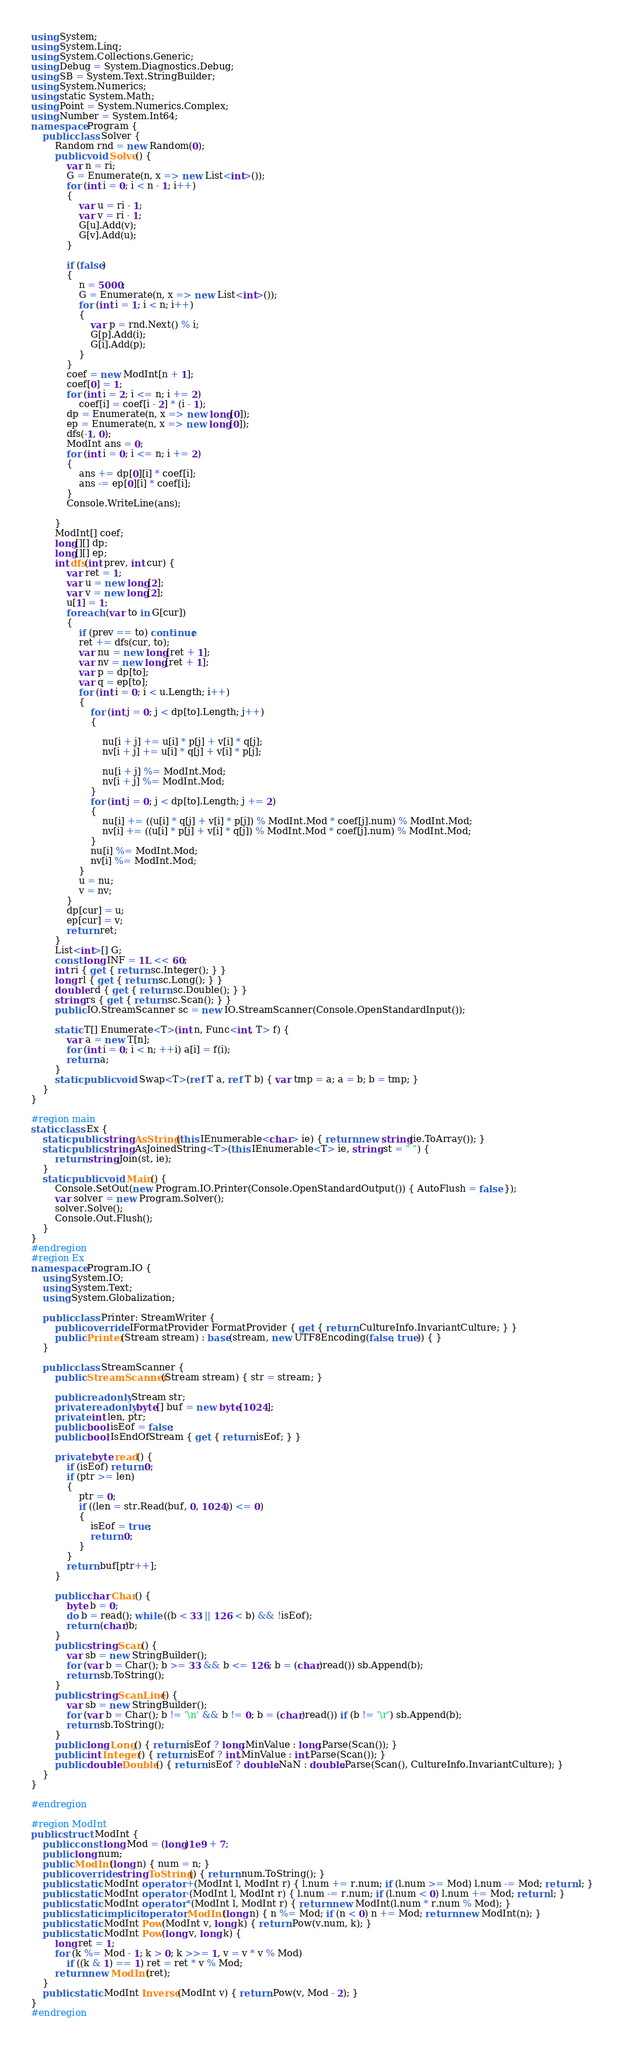<code> <loc_0><loc_0><loc_500><loc_500><_C#_>using System;
using System.Linq;
using System.Collections.Generic;
using Debug = System.Diagnostics.Debug;
using SB = System.Text.StringBuilder;
using System.Numerics;
using static System.Math;
using Point = System.Numerics.Complex;
using Number = System.Int64;
namespace Program {
    public class Solver {
        Random rnd = new Random(0);
        public void Solve() {
            var n = ri;
            G = Enumerate(n, x => new List<int>());
            for (int i = 0; i < n - 1; i++)
            {
                var u = ri - 1;
                var v = ri - 1;
                G[u].Add(v);
                G[v].Add(u);
            }

            if (false)
            {
                n = 5000;
                G = Enumerate(n, x => new List<int>());
                for (int i = 1; i < n; i++)
                {
                    var p = rnd.Next() % i;
                    G[p].Add(i);
                    G[i].Add(p);
                }
            }
            coef = new ModInt[n + 1];
            coef[0] = 1;
            for (int i = 2; i <= n; i += 2)
                coef[i] = coef[i - 2] * (i - 1);
            dp = Enumerate(n, x => new long[0]);
            ep = Enumerate(n, x => new long[0]);
            dfs(-1, 0);
            ModInt ans = 0;
            for (int i = 0; i <= n; i += 2)
            {
                ans += dp[0][i] * coef[i];
                ans -= ep[0][i] * coef[i];
            }
            Console.WriteLine(ans);

        }
        ModInt[] coef;
        long[][] dp;
        long[][] ep;
        int dfs(int prev, int cur) {
            var ret = 1;
            var u = new long[2];
            var v = new long[2];
            u[1] = 1;
            foreach (var to in G[cur])
            {
                if (prev == to) continue;
                ret += dfs(cur, to);
                var nu = new long[ret + 1];
                var nv = new long[ret + 1];
                var p = dp[to];
                var q = ep[to];
                for (int i = 0; i < u.Length; i++)
                {
                    for (int j = 0; j < dp[to].Length; j++)
                    {

                        nu[i + j] += u[i] * p[j] + v[i] * q[j];
                        nv[i + j] += u[i] * q[j] + v[i] * p[j];

                        nu[i + j] %= ModInt.Mod;
                        nv[i + j] %= ModInt.Mod;
                    }
                    for (int j = 0; j < dp[to].Length; j += 2)
                    {
                        nu[i] += ((u[i] * q[j] + v[i] * p[j]) % ModInt.Mod * coef[j].num) % ModInt.Mod;
                        nv[i] += ((u[i] * p[j] + v[i] * q[j]) % ModInt.Mod * coef[j].num) % ModInt.Mod;
                    }
                    nu[i] %= ModInt.Mod;
                    nv[i] %= ModInt.Mod;
                }
                u = nu;
                v = nv;
            }
            dp[cur] = u;
            ep[cur] = v;
            return ret;
        }
        List<int>[] G;
        const long INF = 1L << 60;
        int ri { get { return sc.Integer(); } }
        long rl { get { return sc.Long(); } }
        double rd { get { return sc.Double(); } }
        string rs { get { return sc.Scan(); } }
        public IO.StreamScanner sc = new IO.StreamScanner(Console.OpenStandardInput());

        static T[] Enumerate<T>(int n, Func<int, T> f) {
            var a = new T[n];
            for (int i = 0; i < n; ++i) a[i] = f(i);
            return a;
        }
        static public void Swap<T>(ref T a, ref T b) { var tmp = a; a = b; b = tmp; }
    }
}

#region main
static class Ex {
    static public string AsString(this IEnumerable<char> ie) { return new string(ie.ToArray()); }
    static public string AsJoinedString<T>(this IEnumerable<T> ie, string st = " ") {
        return string.Join(st, ie);
    }
    static public void Main() {
        Console.SetOut(new Program.IO.Printer(Console.OpenStandardOutput()) { AutoFlush = false });
        var solver = new Program.Solver();
        solver.Solve();
        Console.Out.Flush();
    }
}
#endregion
#region Ex
namespace Program.IO {
    using System.IO;
    using System.Text;
    using System.Globalization;

    public class Printer: StreamWriter {
        public override IFormatProvider FormatProvider { get { return CultureInfo.InvariantCulture; } }
        public Printer(Stream stream) : base(stream, new UTF8Encoding(false, true)) { }
    }

    public class StreamScanner {
        public StreamScanner(Stream stream) { str = stream; }

        public readonly Stream str;
        private readonly byte[] buf = new byte[1024];
        private int len, ptr;
        public bool isEof = false;
        public bool IsEndOfStream { get { return isEof; } }

        private byte read() {
            if (isEof) return 0;
            if (ptr >= len)
            {
                ptr = 0;
                if ((len = str.Read(buf, 0, 1024)) <= 0)
                {
                    isEof = true;
                    return 0;
                }
            }
            return buf[ptr++];
        }

        public char Char() {
            byte b = 0;
            do b = read(); while ((b < 33 || 126 < b) && !isEof);
            return (char)b;
        }
        public string Scan() {
            var sb = new StringBuilder();
            for (var b = Char(); b >= 33 && b <= 126; b = (char)read()) sb.Append(b);
            return sb.ToString();
        }
        public string ScanLine() {
            var sb = new StringBuilder();
            for (var b = Char(); b != '\n' && b != 0; b = (char)read()) if (b != '\r') sb.Append(b);
            return sb.ToString();
        }
        public long Long() { return isEof ? long.MinValue : long.Parse(Scan()); }
        public int Integer() { return isEof ? int.MinValue : int.Parse(Scan()); }
        public double Double() { return isEof ? double.NaN : double.Parse(Scan(), CultureInfo.InvariantCulture); }
    }
}

#endregion

#region ModInt
public struct ModInt {
    public const long Mod = (long)1e9 + 7;
    public long num;
    public ModInt(long n) { num = n; }
    public override string ToString() { return num.ToString(); }
    public static ModInt operator +(ModInt l, ModInt r) { l.num += r.num; if (l.num >= Mod) l.num -= Mod; return l; }
    public static ModInt operator -(ModInt l, ModInt r) { l.num -= r.num; if (l.num < 0) l.num += Mod; return l; }
    public static ModInt operator *(ModInt l, ModInt r) { return new ModInt(l.num * r.num % Mod); }
    public static implicit operator ModInt(long n) { n %= Mod; if (n < 0) n += Mod; return new ModInt(n); }
    public static ModInt Pow(ModInt v, long k) { return Pow(v.num, k); }
    public static ModInt Pow(long v, long k) {
        long ret = 1;
        for (k %= Mod - 1; k > 0; k >>= 1, v = v * v % Mod)
            if ((k & 1) == 1) ret = ret * v % Mod;
        return new ModInt(ret);
    }
    public static ModInt Inverse(ModInt v) { return Pow(v, Mod - 2); }
}
#endregion</code> 